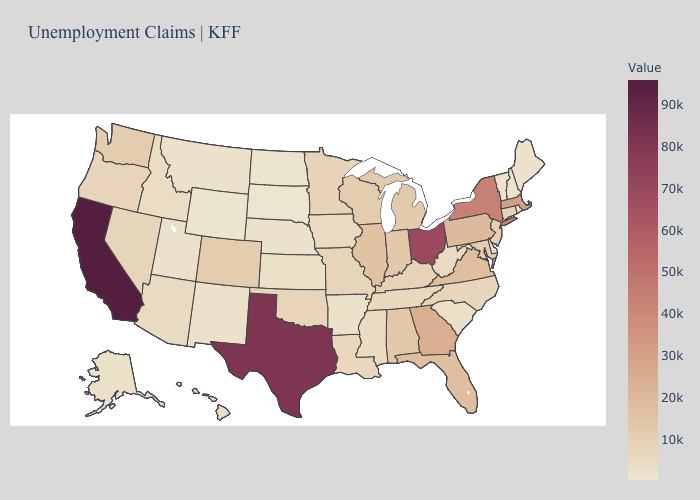Does Michigan have the highest value in the USA?
Keep it brief. No. Is the legend a continuous bar?
Short answer required. Yes. Does California have the highest value in the West?
Concise answer only. Yes. Among the states that border Tennessee , which have the highest value?
Keep it brief. Georgia. Among the states that border Iowa , which have the lowest value?
Short answer required. South Dakota. Is the legend a continuous bar?
Short answer required. Yes. Does Colorado have the lowest value in the West?
Write a very short answer. No. Among the states that border Utah , which have the highest value?
Answer briefly. Colorado. Does New York have the lowest value in the Northeast?
Short answer required. No. 